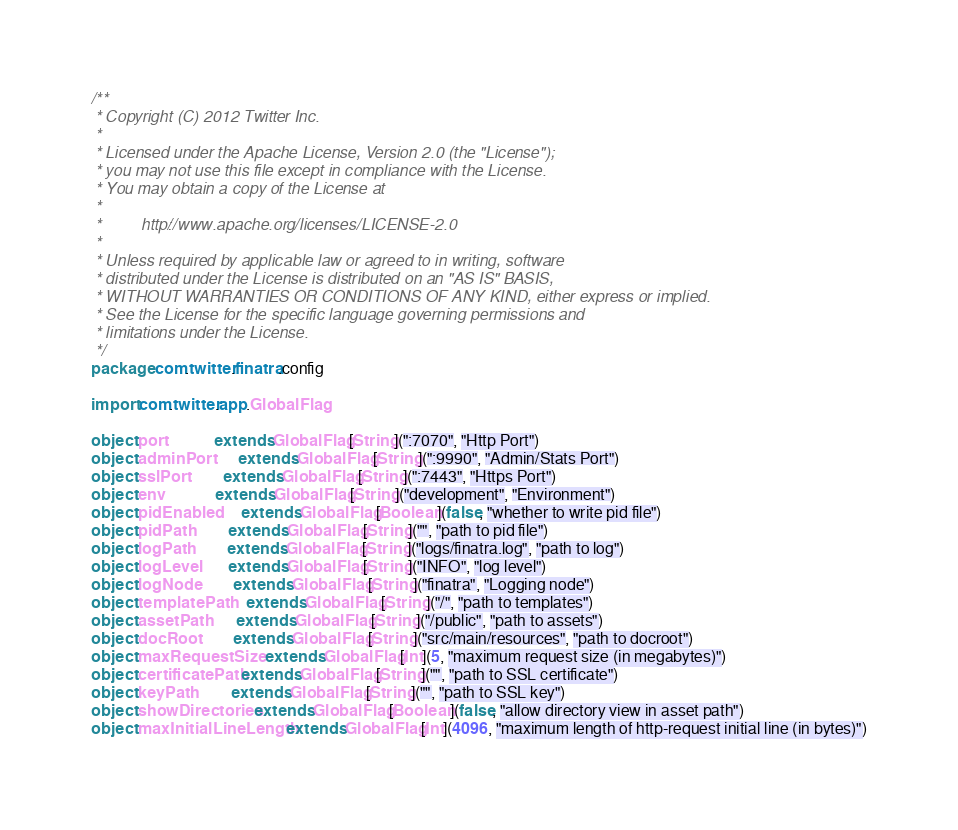<code> <loc_0><loc_0><loc_500><loc_500><_Scala_>/**
 * Copyright (C) 2012 Twitter Inc.
 *
 * Licensed under the Apache License, Version 2.0 (the "License");
 * you may not use this file except in compliance with the License.
 * You may obtain a copy of the License at
 *
 *         http://www.apache.org/licenses/LICENSE-2.0
 *
 * Unless required by applicable law or agreed to in writing, software
 * distributed under the License is distributed on an "AS IS" BASIS,
 * WITHOUT WARRANTIES OR CONDITIONS OF ANY KIND, either express or implied.
 * See the License for the specific language governing permissions and
 * limitations under the License.
 */
package com.twitter.finatra.config

import com.twitter.app.GlobalFlag

object port            extends GlobalFlag[String](":7070", "Http Port")
object adminPort       extends GlobalFlag[String](":9990", "Admin/Stats Port")
object sslPort         extends GlobalFlag[String](":7443", "Https Port")
object env             extends GlobalFlag[String]("development", "Environment")
object pidEnabled      extends GlobalFlag[Boolean](false, "whether to write pid file")
object pidPath         extends GlobalFlag[String]("", "path to pid file")
object logPath         extends GlobalFlag[String]("logs/finatra.log", "path to log")
object logLevel        extends GlobalFlag[String]("INFO", "log level")
object logNode         extends GlobalFlag[String]("finatra", "Logging node")
object templatePath    extends GlobalFlag[String]("/", "path to templates")
object assetPath       extends GlobalFlag[String]("/public", "path to assets")
object docRoot         extends GlobalFlag[String]("src/main/resources", "path to docroot")
object maxRequestSize  extends GlobalFlag[Int](5, "maximum request size (in megabytes)")
object certificatePath extends GlobalFlag[String]("", "path to SSL certificate")
object keyPath         extends GlobalFlag[String]("", "path to SSL key")
object showDirectories extends GlobalFlag[Boolean](false, "allow directory view in asset path")
object maxInitialLineLength extends GlobalFlag[Int](4096, "maximum length of http-request initial line (in bytes)")
</code> 